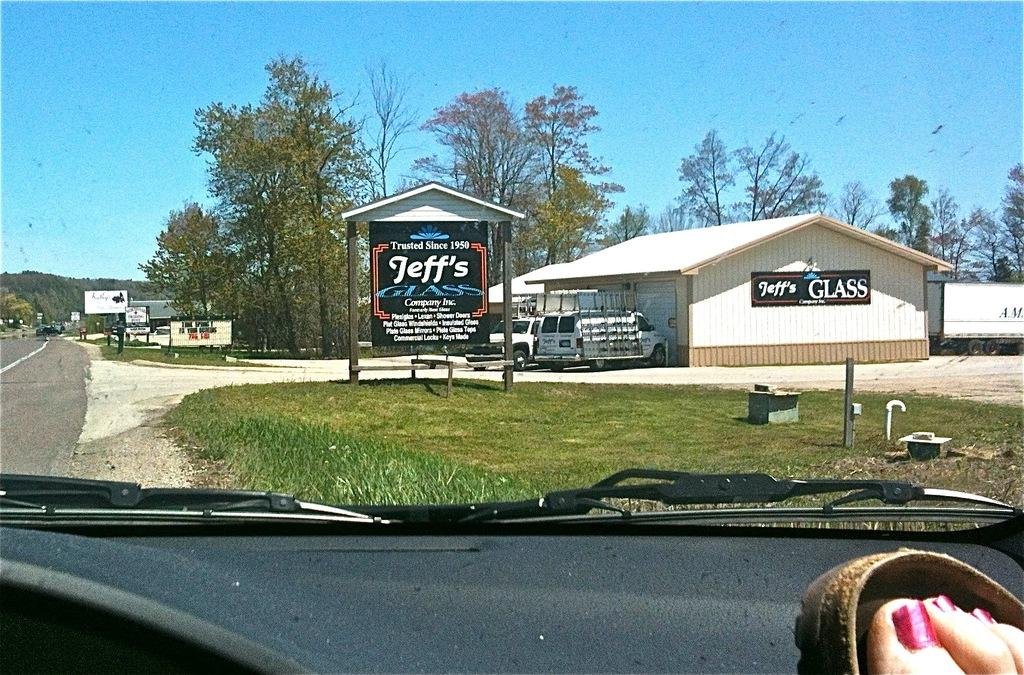What is the main subject of the image? The main subject of the image is a person's leg inside a vehicle. What type of environment is visible in the image? The environment includes grass, a road, trees, houses, and the sky. What other vehicles are present in the image? Other vehicles are present in the image. What additional objects can be seen in the image? Name boards, banners, and various other objects are visible in the image. What color is the iron square in the image? There is no iron square present in the image. 